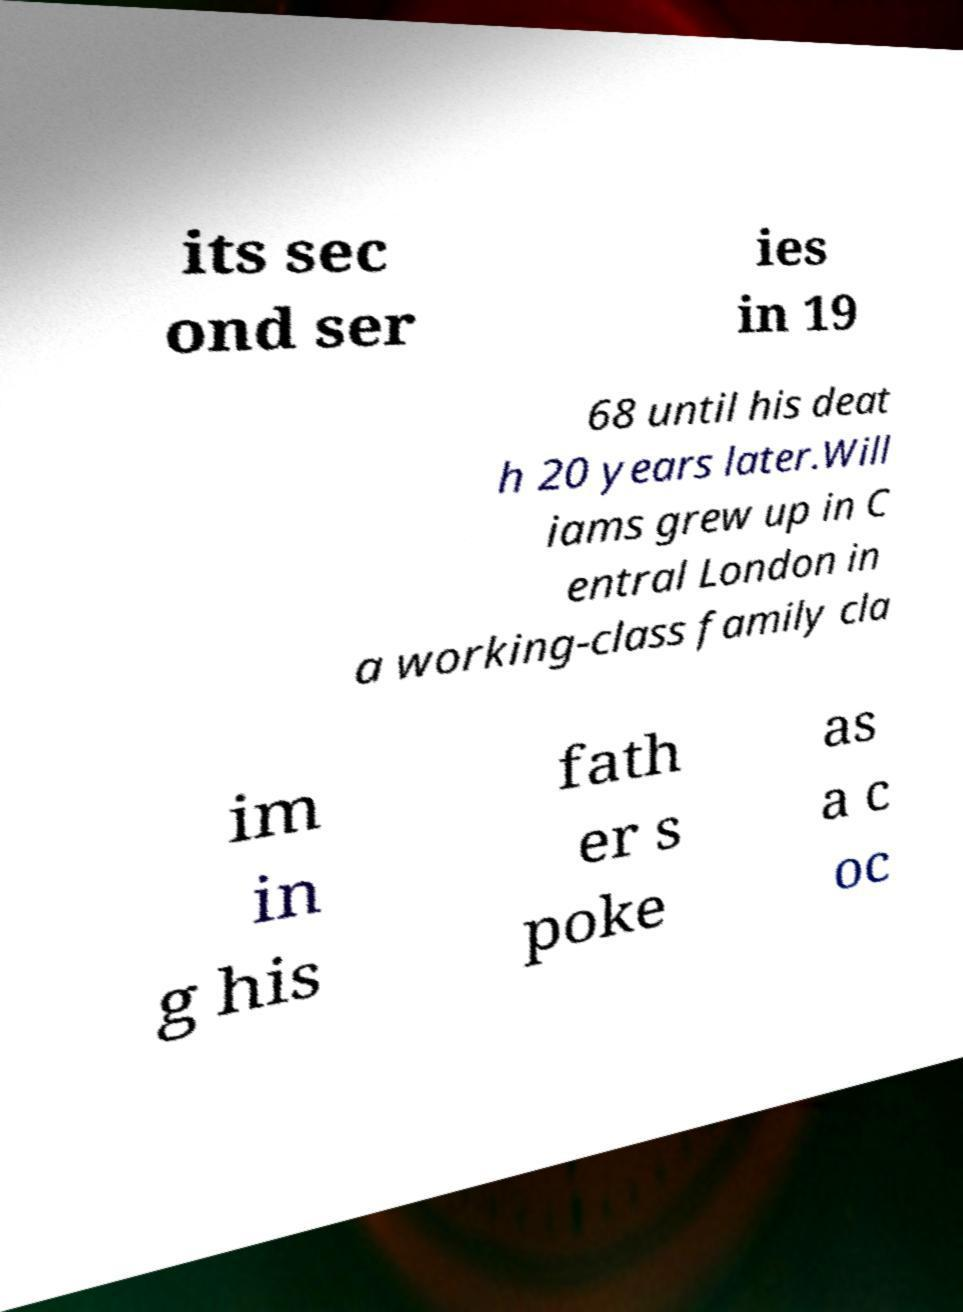There's text embedded in this image that I need extracted. Can you transcribe it verbatim? its sec ond ser ies in 19 68 until his deat h 20 years later.Will iams grew up in C entral London in a working-class family cla im in g his fath er s poke as a c oc 